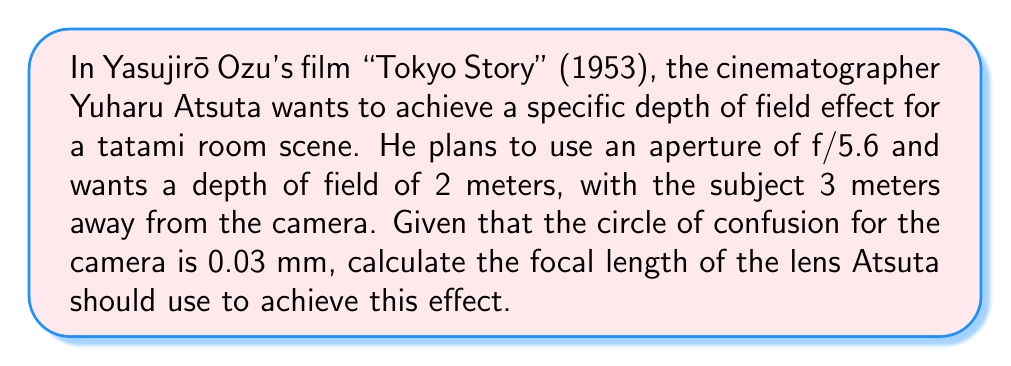What is the answer to this math problem? To solve this problem, we'll use the depth of field equation and work backwards to find the focal length. Let's break it down step-by-step:

1) The depth of field equation is:
   $$DoF = \frac{2Ncf(s^2)}{f^2 - N^2c^2}$$
   where:
   $DoF$ = Depth of Field
   $N$ = f-number (aperture)
   $c$ = circle of confusion
   $f$ = focal length
   $s$ = subject distance

2) We know:
   $DoF = 2$ m
   $N = 5.6$
   $c = 0.03$ mm = $0.00003$ m
   $s = 3$ m

3) Let's substitute these values into the equation:
   $$2 = \frac{2 \cdot 5.6 \cdot 0.00003 \cdot f \cdot (3^2)}{f^2 - (5.6^2 \cdot 0.00003^2)}$$

4) Simplify:
   $$2 = \frac{0.003024f}{f^2 - 0.0000000282}$$

5) Multiply both sides by $(f^2 - 0.0000000282)$:
   $$2f^2 - 0.0000000564 = 0.003024f$$

6) Rearrange to standard quadratic form:
   $$2f^2 - 0.003024f - 0.0000000564 = 0$$

7) Use the quadratic formula to solve for $f$:
   $$f = \frac{-b \pm \sqrt{b^2 - 4ac}}{2a}$$
   where $a = 2$, $b = -0.003024$, and $c = -0.0000000564$

8) Plugging in these values:
   $$f = \frac{0.003024 \pm \sqrt{0.003024^2 - 4(2)(-0.0000000564)}}{2(2)}$$

9) Solve:
   $$f \approx 0.0507\text{ m or }-0.0492\text{ m}$$

10) Since focal length can't be negative, we take the positive solution.

11) Convert to mm:
    $$f \approx 50.7\text{ mm}$$
Answer: The focal length Atsuta should use is approximately 50.7 mm. 